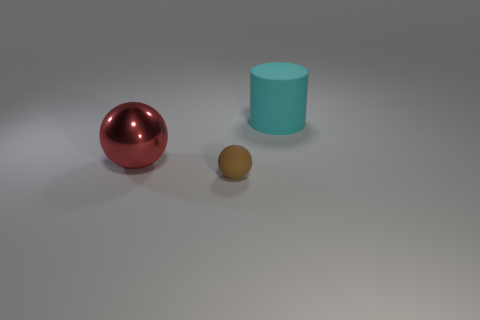Add 3 large rubber objects. How many objects exist? 6 Subtract all cylinders. How many objects are left? 2 Subtract 0 brown cylinders. How many objects are left? 3 Subtract all small brown rubber cubes. Subtract all big cyan rubber cylinders. How many objects are left? 2 Add 1 balls. How many balls are left? 3 Add 3 cyan matte cylinders. How many cyan matte cylinders exist? 4 